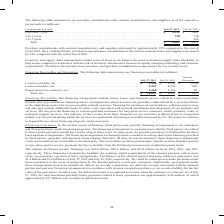According to Cisco Systems's financial document, Why is inventory and supply chain management an area of focus for the company? we balance the need to maintain supply chain flexibility to help ensure competitive lead times with the risk of inventory obsolescence because of rapidly changing technology and customer requirements.. The document states: "d supply chain management remain areas of focus as we balance the need to maintain supply chain flexibility to help ensure competitive lead times with..." Also, What were the purchase commitments that were less than 1 year in 2019? According to the financial document, 4,239 (in millions). The relevant text states: "July 27, 2019 July 28, 2018 Less than 1 year. . $ 4,239 $ 5,407 1 to 3 years. . 728 710 3 to 5 years. . — 360 Total . $ 4,967 $ 6,477..." Also, What were the total purchase commitments in 2018? According to the financial document, 6,477 (in millions). The relevant text states: ". 728 710 3 to 5 years. . — 360 Total . $ 4,967 $ 6,477..." Also, can you calculate: What was the change in purchase commitments that were less than 1 year between 2018 and 2019? Based on the calculation: 4,239-5,407, the result is -1168 (in millions). This is based on the information: "2019 July 28, 2018 Less than 1 year. . $ 4,239 $ 5,407 1 to 3 years. . 728 710 3 to 5 years. . — 360 Total . $ 4,967 $ 6,477 July 27, 2019 July 28, 2018 Less than 1 year. . $ 4,239 $ 5,407 1 to 3 year..." The key data points involved are: 4,239, 5,407. Also, How many years did commitments that were 1 to 3 years exceed $700 million? Counting the relevant items in the document: 2019, 2018, I find 2 instances. The key data points involved are: 2018, 2019. Also, can you calculate: What were the commitments that were less than 1 year as a percentage of total purchase commitments in 2019? Based on the calculation: 4,239/4,967, the result is 85.34 (percentage). This is based on the information: "July 27, 2019 July 28, 2018 Less than 1 year. . $ 4,239 $ 5,407 1 to 3 years. . 728 710 3 to 5 years. . — 360 Total . $ 4,967 $ 6,477 years. . 728 710 3 to 5 years. . — 360 Total . $ 4,967 $ 6,477..." The key data points involved are: 4,239, 4,967. 